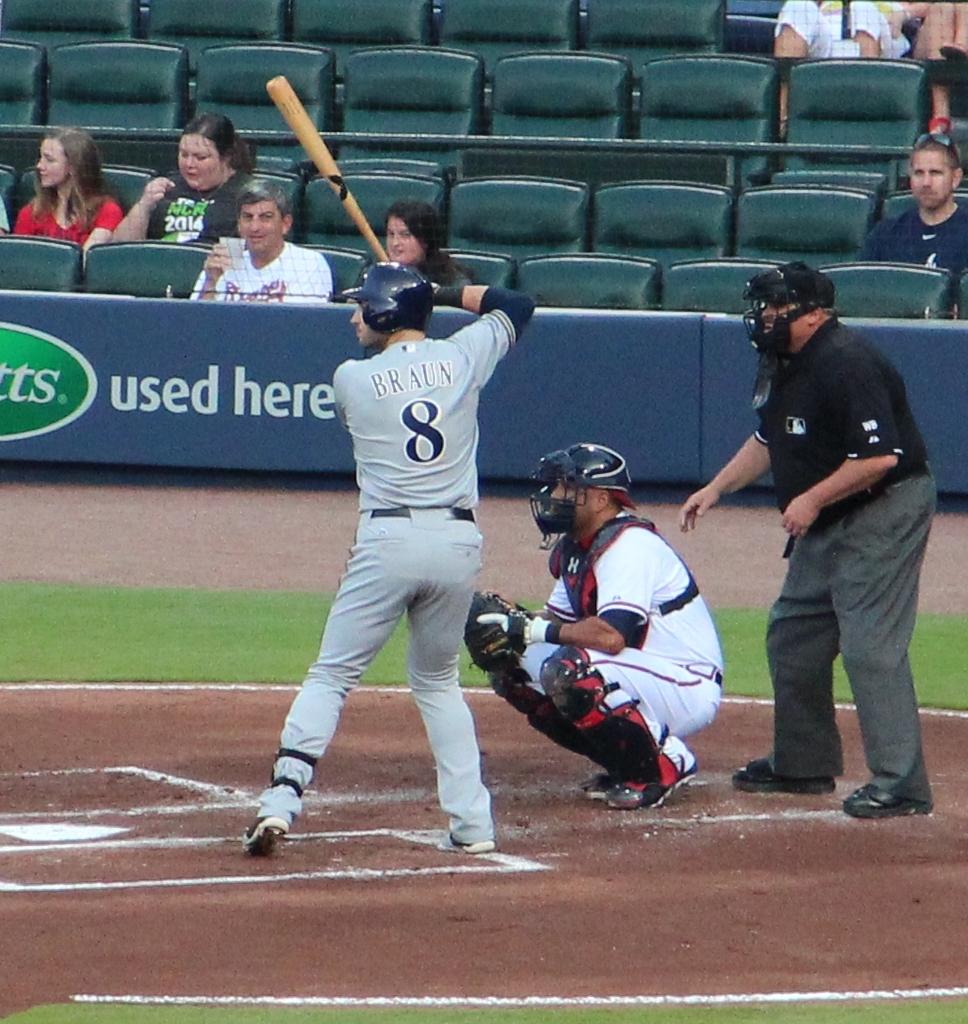What is the batters player number?
Your answer should be very brief. 8. What is the name on the player's shirt with number 8 ?
Your response must be concise. Braun. 